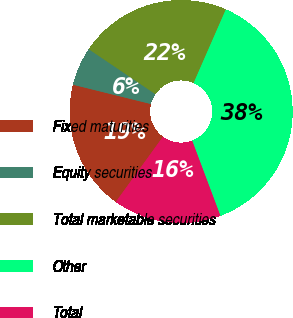Convert chart. <chart><loc_0><loc_0><loc_500><loc_500><pie_chart><fcel>Fixed maturities<fcel>Equity securities<fcel>Total marketable securities<fcel>Other<fcel>Total<nl><fcel>18.9%<fcel>5.58%<fcel>22.12%<fcel>37.71%<fcel>15.69%<nl></chart> 